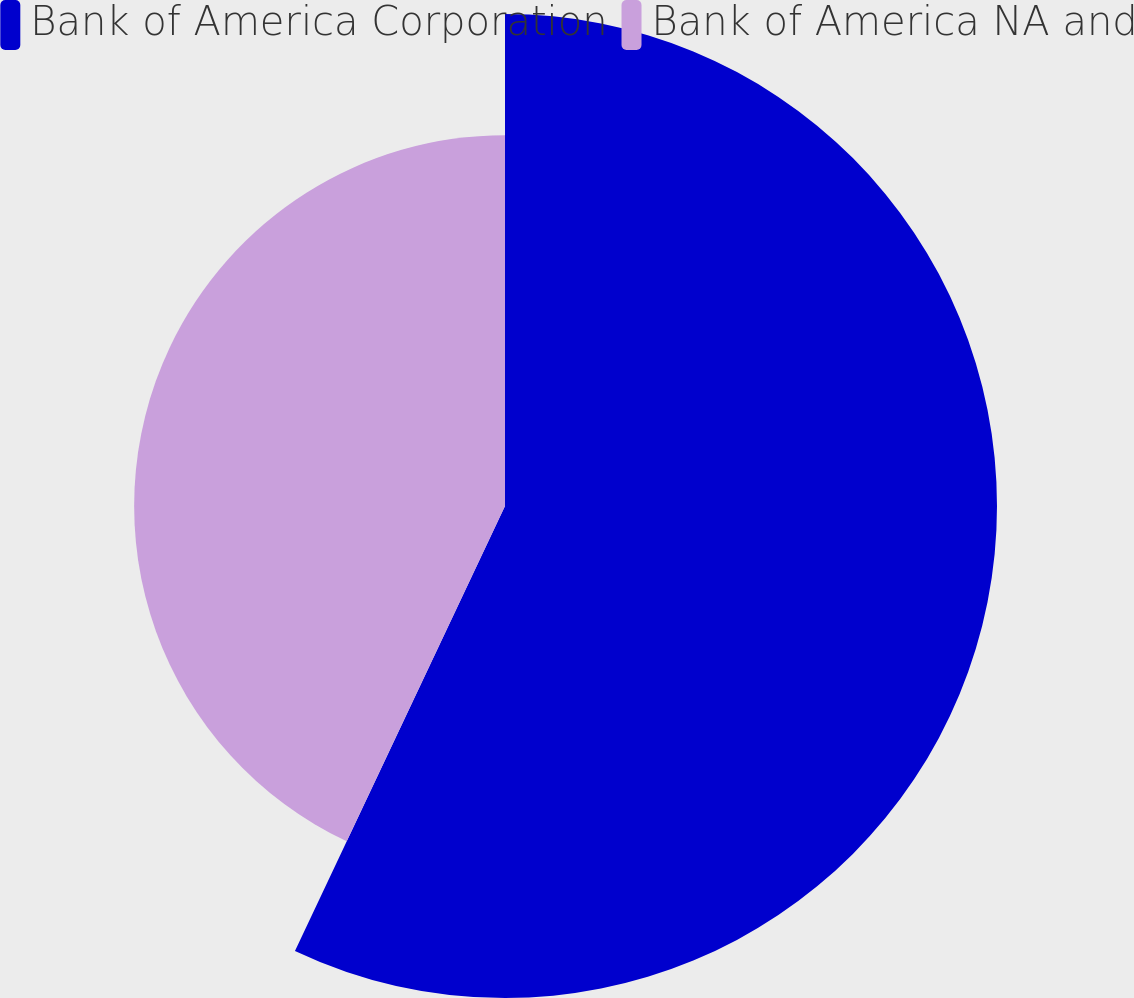Convert chart. <chart><loc_0><loc_0><loc_500><loc_500><pie_chart><fcel>Bank of America Corporation<fcel>Bank of America NA and<nl><fcel>57.02%<fcel>42.98%<nl></chart> 